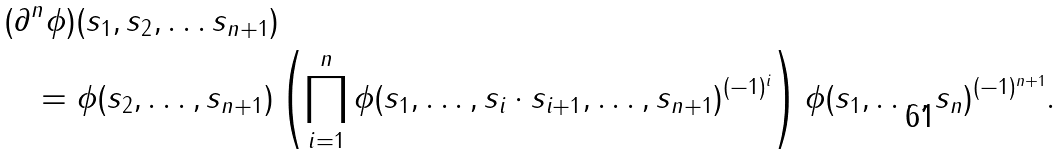Convert formula to latex. <formula><loc_0><loc_0><loc_500><loc_500>( \partial & ^ { n } \phi ) ( s _ { 1 } , s _ { 2 } , \dots s _ { n + 1 } ) \\ & = \phi ( s _ { 2 } , \dots , s _ { n + 1 } ) \left ( \prod _ { i = 1 } ^ { n } \phi ( s _ { 1 } , \dots , s _ { i } \cdot s _ { i + 1 } , \dots , s _ { n + 1 } ) ^ { ( - 1 ) ^ { i } } \right ) \phi ( s _ { 1 } , \dots , s _ { n } ) ^ { ( - 1 ) ^ { n + 1 } } .</formula> 